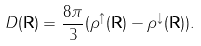<formula> <loc_0><loc_0><loc_500><loc_500>D ( \mathbf R ) = \frac { 8 \pi } 3 ( \rho ^ { \uparrow } ( \mathbf R ) - \rho ^ { \downarrow } ( \mathbf R ) ) .</formula> 